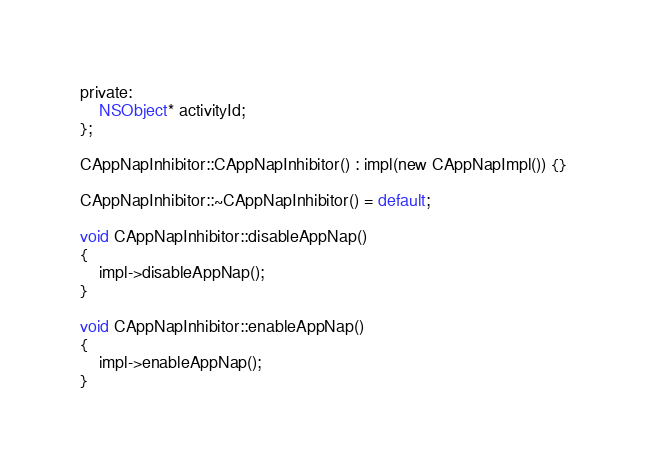<code> <loc_0><loc_0><loc_500><loc_500><_ObjectiveC_>private:
    NSObject* activityId;
};

CAppNapInhibitor::CAppNapInhibitor() : impl(new CAppNapImpl()) {}

CAppNapInhibitor::~CAppNapInhibitor() = default;

void CAppNapInhibitor::disableAppNap()
{
    impl->disableAppNap();
}

void CAppNapInhibitor::enableAppNap()
{
    impl->enableAppNap();
}
</code> 